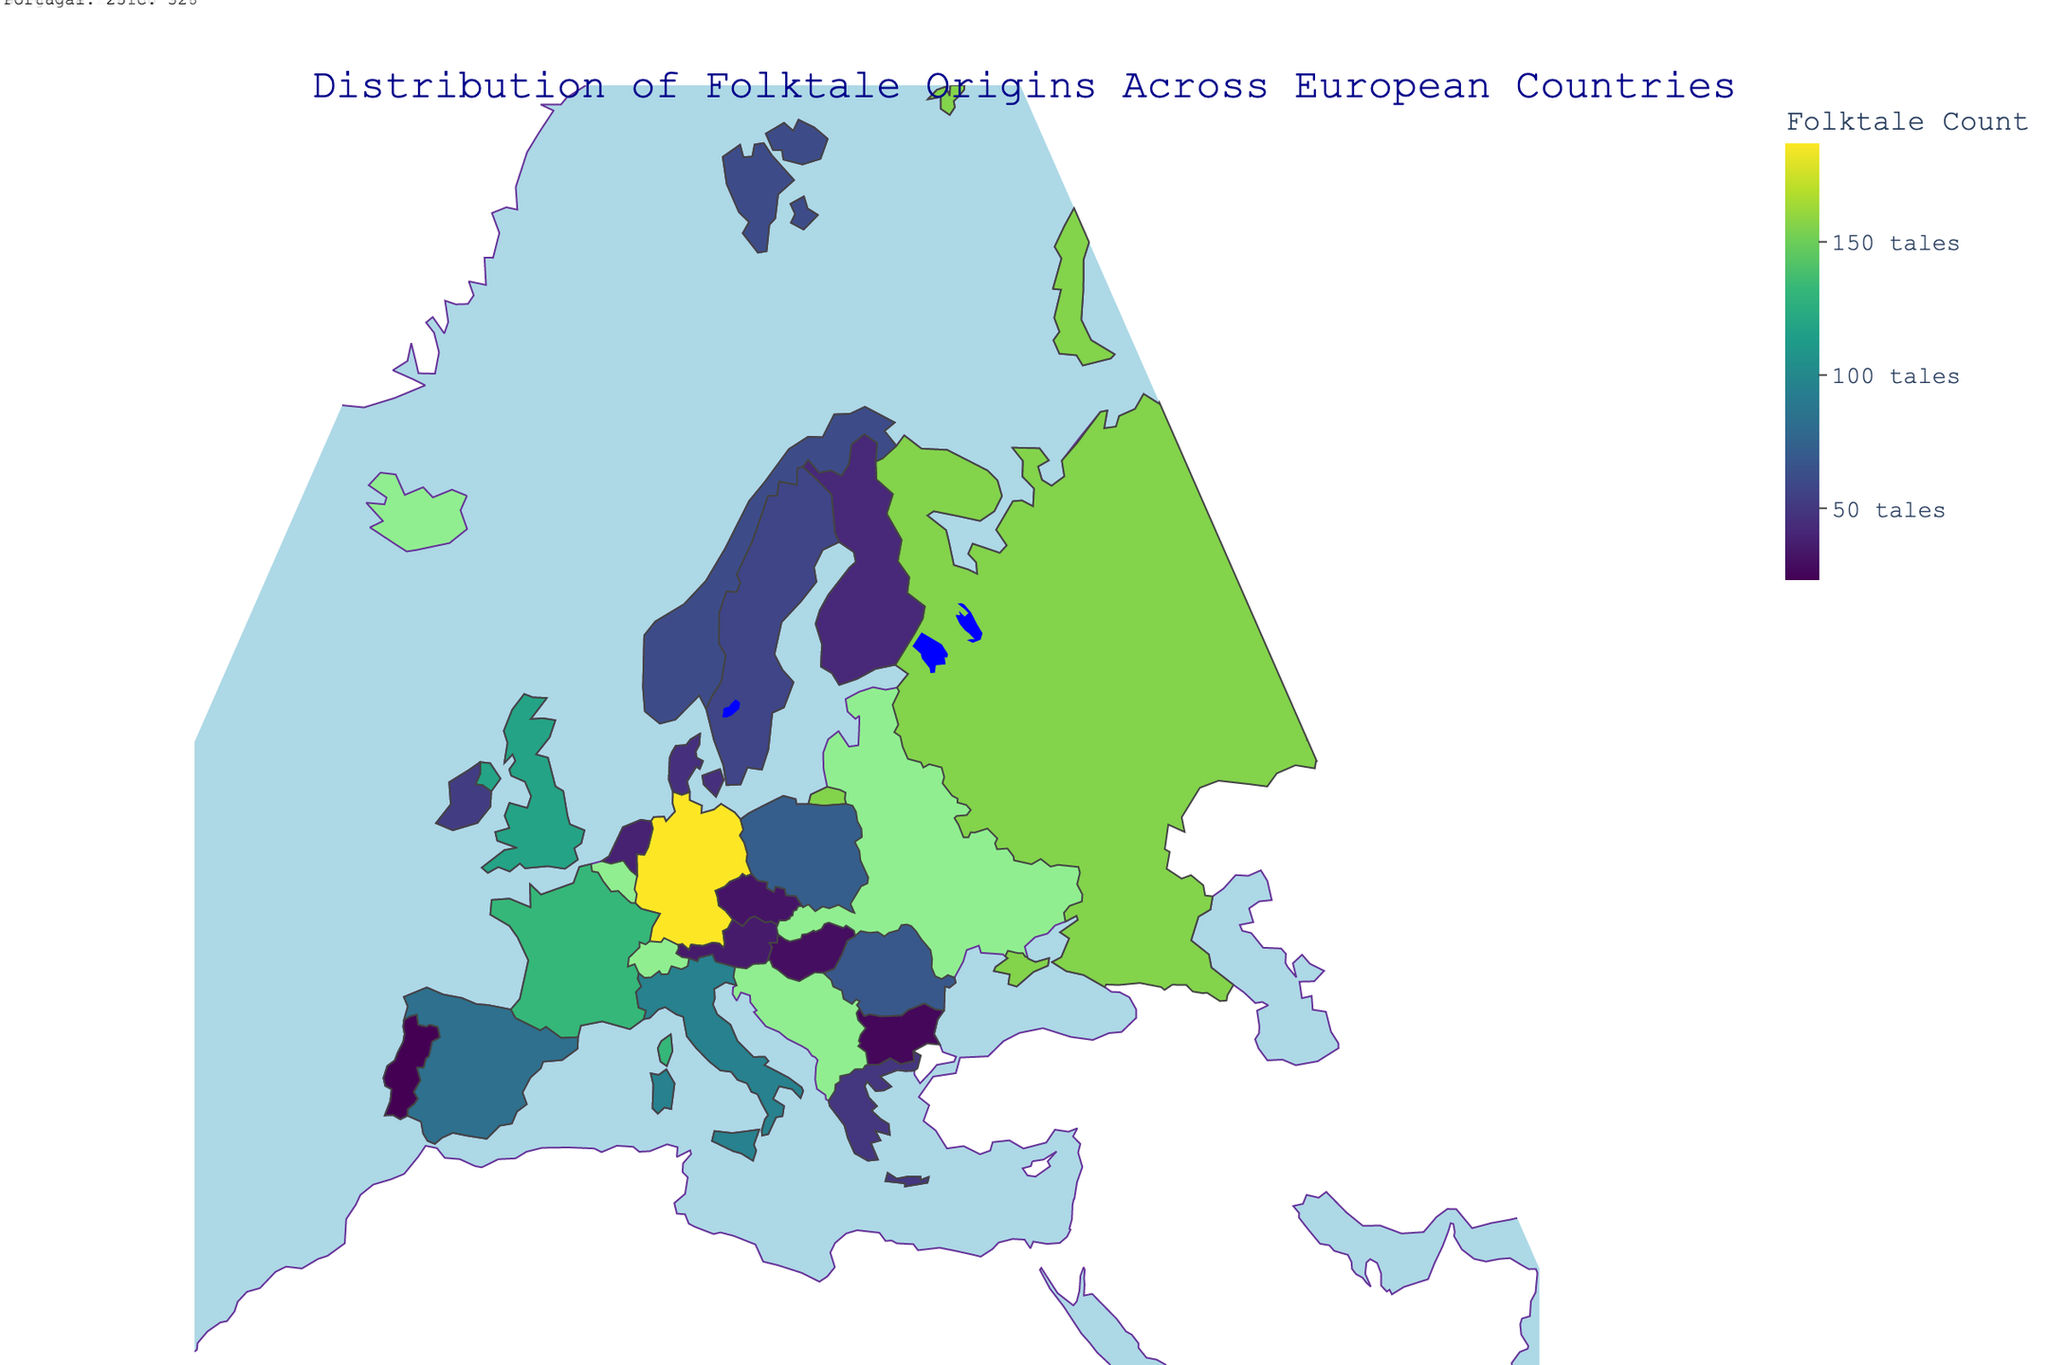What is the title of the figure? The title is displayed at the top of the figure. It provides a summary of what the figure depicts.
Answer: Distribution of Folktale Origins Across European Countries Which country has the highest count of folktales? By inspecting the color intensity and the annotations in the figure, you can see which country is shaded the darkest and has the corresponding annotation with the highest number.
Answer: Germany How many folktales originate from France? Look at the annotation or hover over France on the map to see the exact number of folktales originating from there.
Answer: 132 Which country has more folktales, Sweden or Portugal? Compare the folktale counts shown next to the annotations or hover over each country to check their counts.
Answer: Sweden What is the total number of folktales from the top three countries combined? Add the folktale counts from Germany, Russia, and France: 187 (Germany) + 156 (Russia) + 132 (France).
Answer: 475 Is there any country with exactly 50 folktales? Check the annotations or hover information for each country to see if any has a count of exactly 50.
Answer: No Which countries have folktale counts between 50 and 100? Observe the annotations or hover information for countries with counts within this range: Italy (95), Spain (83), Poland (72), Romania (68), Norway (61), and Sweden (57).
Answer: Italy, Spain, Poland, Romania, Norway, Sweden What is the average folktale count of the bottom five countries? Add the folktale counts from Finland, Netherlands, Austria, Czech Republic, and Hungary, then divide by 5: (41 + 38 + 35 + 32 + 29) / 5 = 35.
Answer: 35 How many more folktales does Ireland have compared to Denmark? Subtract the folktale count of Denmark from that of Ireland: 52 (Ireland) - 45 (Denmark).
Answer: 7 Which Scandinavian country has the highest folktale count? Compare the folktale counts of Norway, Sweden, Denmark, and Finland and find the highest one.
Answer: Norway 